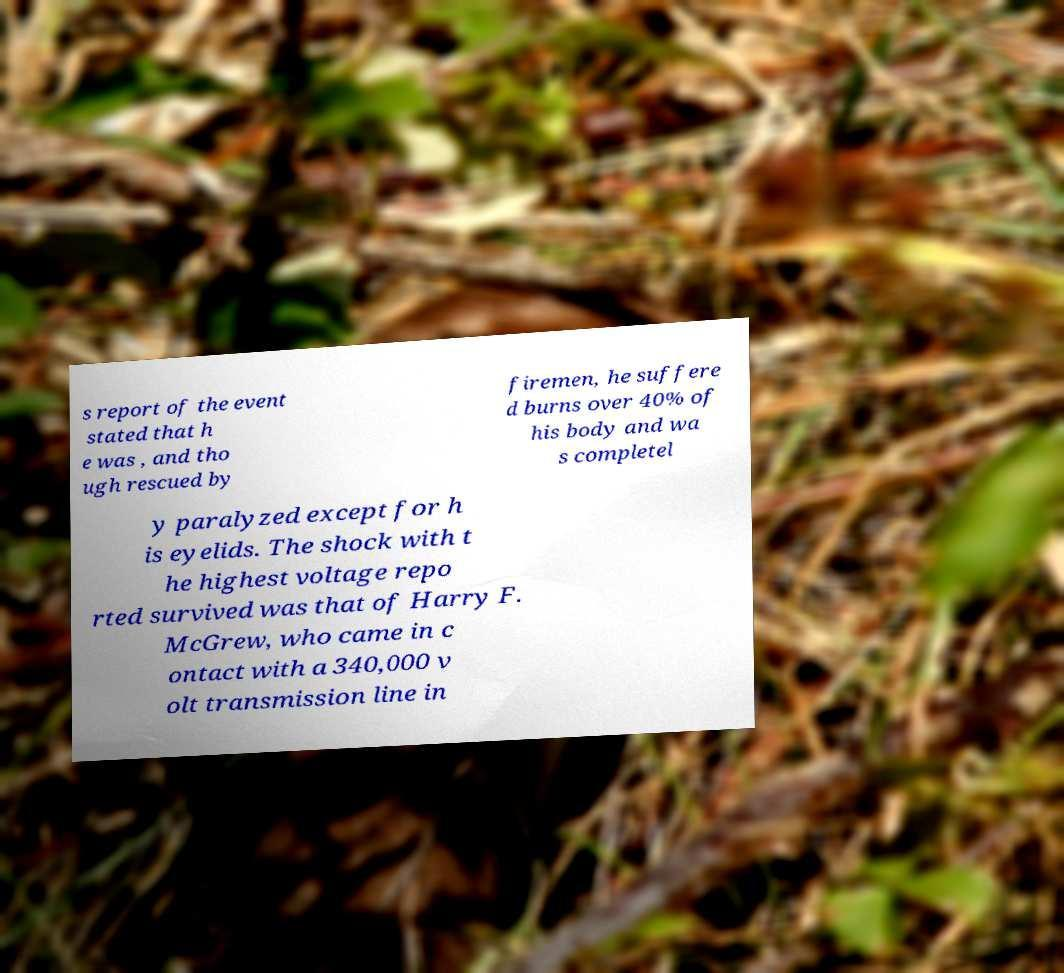Could you assist in decoding the text presented in this image and type it out clearly? s report of the event stated that h e was , and tho ugh rescued by firemen, he suffere d burns over 40% of his body and wa s completel y paralyzed except for h is eyelids. The shock with t he highest voltage repo rted survived was that of Harry F. McGrew, who came in c ontact with a 340,000 v olt transmission line in 